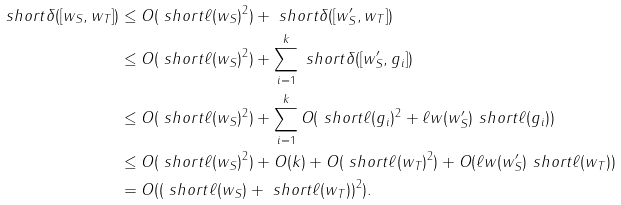<formula> <loc_0><loc_0><loc_500><loc_500>\ s h o r t { \delta } ( [ w _ { S } , w _ { T } ] ) & \leq O ( \ s h o r t { \ell } ( w _ { S } ) ^ { 2 } ) + \ s h o r t { \delta } ( [ w _ { S } ^ { \prime } , w _ { T } ] ) \\ & \leq O ( \ s h o r t { \ell } ( w _ { S } ) ^ { 2 } ) + \sum _ { i = 1 } ^ { k } \ s h o r t { \delta } ( [ w _ { S } ^ { \prime } , g _ { i } ] ) \\ & \leq O ( \ s h o r t { \ell } ( w _ { S } ) ^ { 2 } ) + \sum _ { i = 1 } ^ { k } O ( \ s h o r t { \ell } ( g _ { i } ) ^ { 2 } + \ell w ( w _ { S } ^ { \prime } ) \ s h o r t { \ell } ( g _ { i } ) ) \\ & \leq O ( \ s h o r t { \ell } ( w _ { S } ) ^ { 2 } ) + O ( k ) + O ( \ s h o r t { \ell } ( w _ { T } ) ^ { 2 } ) + O ( \ell w ( w _ { S } ^ { \prime } ) \ s h o r t { \ell } ( w _ { T } ) ) \\ & = O ( ( \ s h o r t { \ell } ( w _ { S } ) + \ s h o r t { \ell } ( w _ { T } ) ) ^ { 2 } ) .</formula> 